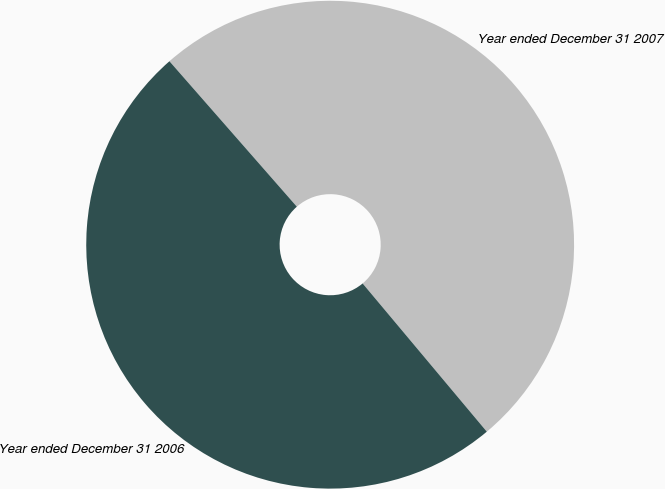Convert chart to OTSL. <chart><loc_0><loc_0><loc_500><loc_500><pie_chart><fcel>Year ended December 31 2007<fcel>Year ended December 31 2006<nl><fcel>50.35%<fcel>49.65%<nl></chart> 